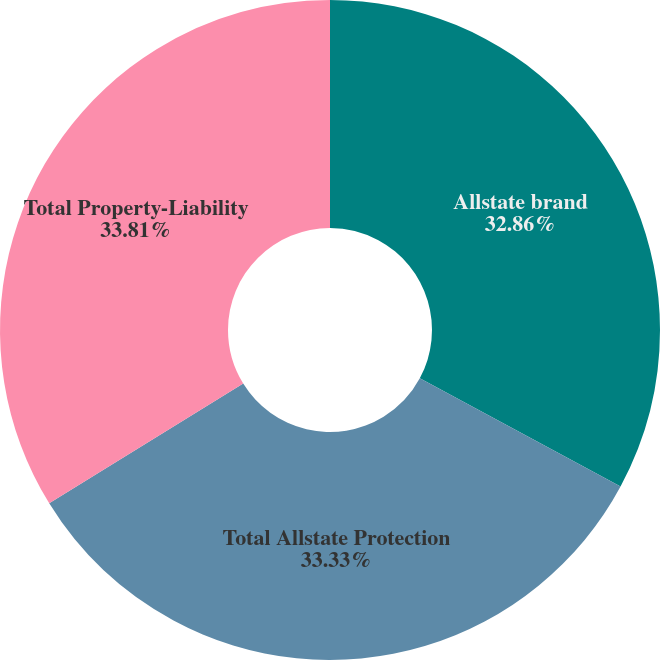<chart> <loc_0><loc_0><loc_500><loc_500><pie_chart><fcel>Allstate brand<fcel>Total Allstate Protection<fcel>Total Property-Liability<nl><fcel>32.86%<fcel>33.33%<fcel>33.8%<nl></chart> 